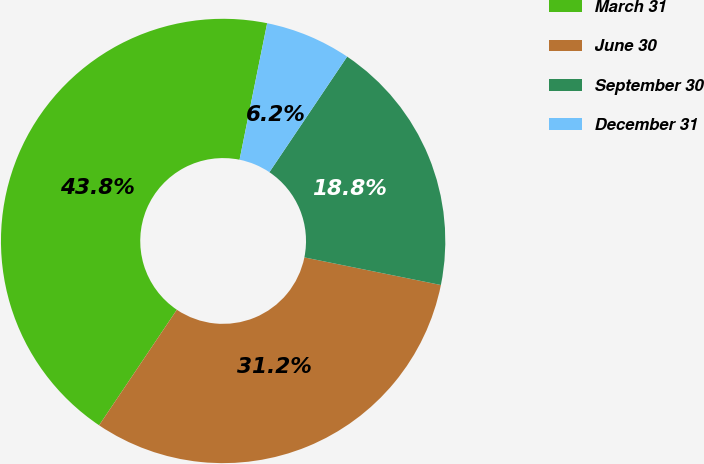<chart> <loc_0><loc_0><loc_500><loc_500><pie_chart><fcel>March 31<fcel>June 30<fcel>September 30<fcel>December 31<nl><fcel>43.75%<fcel>31.25%<fcel>18.75%<fcel>6.25%<nl></chart> 